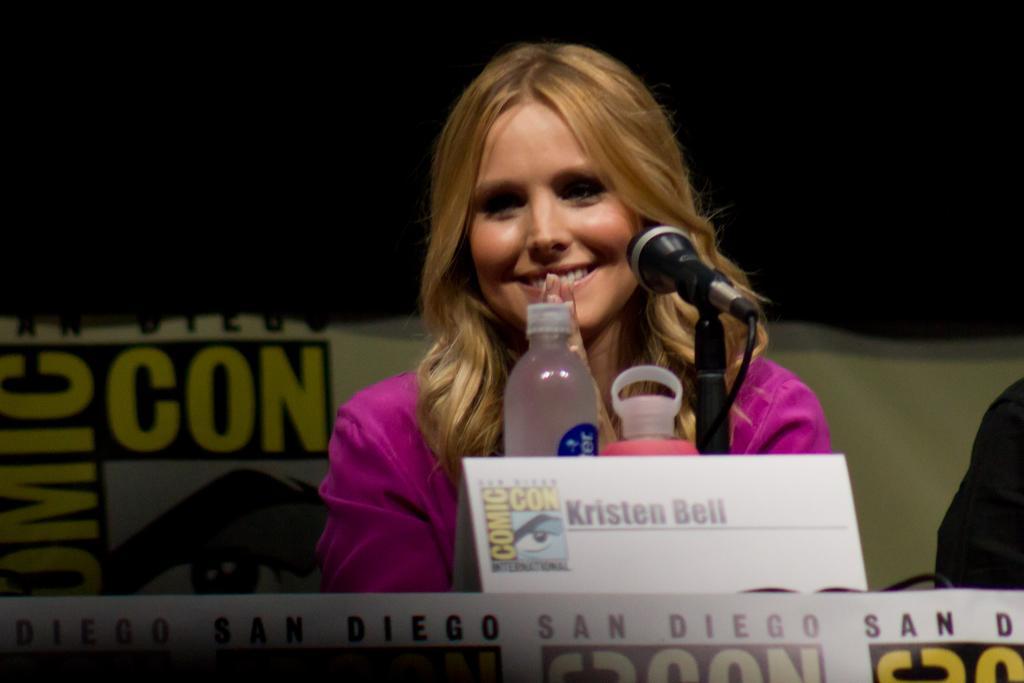Could you give a brief overview of what you see in this image? The picture is taken inside the closed room and one woman is sitting on the chair and she is wearing a pink dress, infront of her there are bottles, microphone and name plate on the table and behind her there is one big poster. 